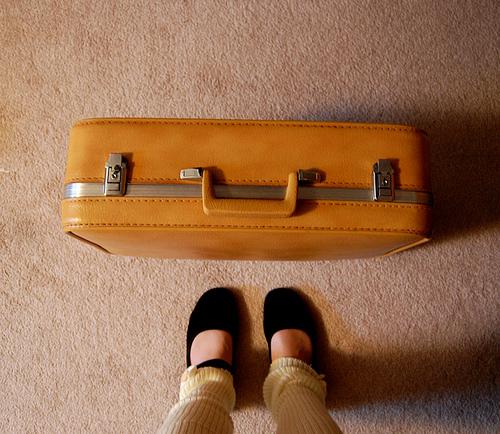Where is this girl going with a suitcase?
Be succinct. Trip. What color are her shoes?
Keep it brief. Black. Are there stains on this carpet?
Quick response, please. No. 